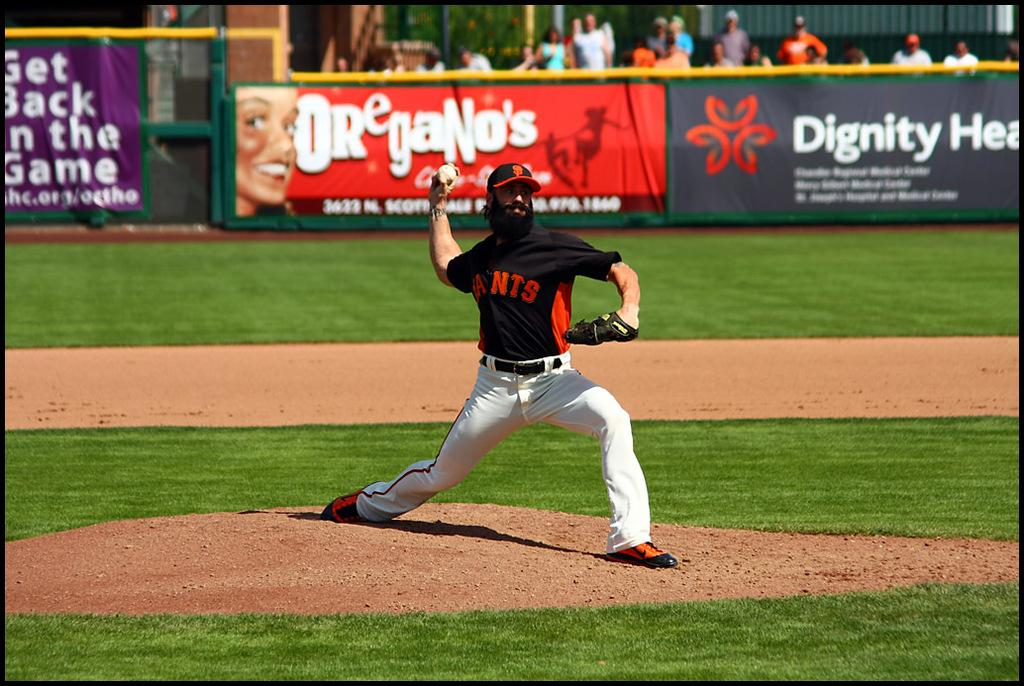<image>
Write a terse but informative summary of the picture. A baseball player with a red and black shirt with the ants logo on the center of his shirt. 